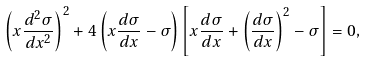Convert formula to latex. <formula><loc_0><loc_0><loc_500><loc_500>\left ( x \frac { d ^ { 2 } \sigma } { d x ^ { 2 } } \right ) ^ { 2 } + 4 \left ( x \frac { d \sigma } { d x } - \sigma \right ) \left [ x \frac { d \sigma } { d x } + \left ( \frac { d \sigma } { d x } \right ) ^ { 2 } - \sigma \right ] = 0 ,</formula> 